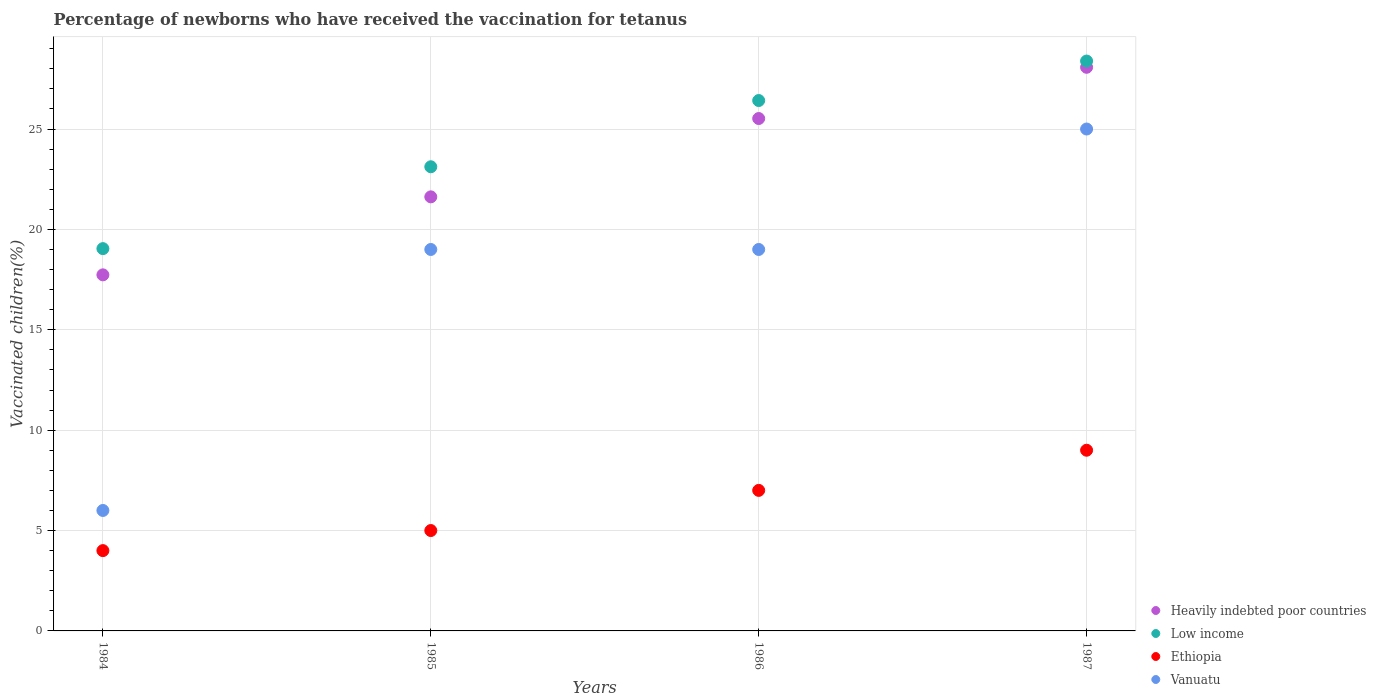How many different coloured dotlines are there?
Your response must be concise. 4. Is the number of dotlines equal to the number of legend labels?
Offer a terse response. Yes. What is the percentage of vaccinated children in Ethiopia in 1987?
Offer a very short reply. 9. Across all years, what is the maximum percentage of vaccinated children in Ethiopia?
Your answer should be very brief. 9. Across all years, what is the minimum percentage of vaccinated children in Low income?
Your answer should be very brief. 19.04. In which year was the percentage of vaccinated children in Heavily indebted poor countries maximum?
Offer a very short reply. 1987. What is the total percentage of vaccinated children in Heavily indebted poor countries in the graph?
Ensure brevity in your answer.  92.95. What is the difference between the percentage of vaccinated children in Low income in 1985 and that in 1986?
Make the answer very short. -3.3. What is the difference between the percentage of vaccinated children in Low income in 1984 and the percentage of vaccinated children in Heavily indebted poor countries in 1986?
Provide a short and direct response. -6.48. What is the average percentage of vaccinated children in Low income per year?
Provide a short and direct response. 24.24. In the year 1985, what is the difference between the percentage of vaccinated children in Ethiopia and percentage of vaccinated children in Heavily indebted poor countries?
Ensure brevity in your answer.  -16.62. In how many years, is the percentage of vaccinated children in Heavily indebted poor countries greater than 13 %?
Provide a succinct answer. 4. What is the ratio of the percentage of vaccinated children in Ethiopia in 1985 to that in 1987?
Keep it short and to the point. 0.56. What is the difference between the highest and the second highest percentage of vaccinated children in Low income?
Make the answer very short. 1.97. What is the difference between the highest and the lowest percentage of vaccinated children in Heavily indebted poor countries?
Give a very brief answer. 10.34. In how many years, is the percentage of vaccinated children in Low income greater than the average percentage of vaccinated children in Low income taken over all years?
Your answer should be very brief. 2. Is the sum of the percentage of vaccinated children in Heavily indebted poor countries in 1986 and 1987 greater than the maximum percentage of vaccinated children in Ethiopia across all years?
Provide a short and direct response. Yes. Is it the case that in every year, the sum of the percentage of vaccinated children in Low income and percentage of vaccinated children in Vanuatu  is greater than the sum of percentage of vaccinated children in Heavily indebted poor countries and percentage of vaccinated children in Ethiopia?
Offer a very short reply. No. Is the percentage of vaccinated children in Vanuatu strictly greater than the percentage of vaccinated children in Ethiopia over the years?
Make the answer very short. Yes. Is the percentage of vaccinated children in Heavily indebted poor countries strictly less than the percentage of vaccinated children in Ethiopia over the years?
Keep it short and to the point. No. How many years are there in the graph?
Your answer should be very brief. 4. What is the difference between two consecutive major ticks on the Y-axis?
Provide a succinct answer. 5. Are the values on the major ticks of Y-axis written in scientific E-notation?
Your answer should be very brief. No. How many legend labels are there?
Offer a terse response. 4. What is the title of the graph?
Ensure brevity in your answer.  Percentage of newborns who have received the vaccination for tetanus. What is the label or title of the Y-axis?
Your answer should be compact. Vaccinated children(%). What is the Vaccinated children(%) of Heavily indebted poor countries in 1984?
Keep it short and to the point. 17.74. What is the Vaccinated children(%) in Low income in 1984?
Ensure brevity in your answer.  19.04. What is the Vaccinated children(%) in Heavily indebted poor countries in 1985?
Ensure brevity in your answer.  21.62. What is the Vaccinated children(%) in Low income in 1985?
Offer a very short reply. 23.12. What is the Vaccinated children(%) of Ethiopia in 1985?
Your response must be concise. 5. What is the Vaccinated children(%) in Vanuatu in 1985?
Ensure brevity in your answer.  19. What is the Vaccinated children(%) of Heavily indebted poor countries in 1986?
Your response must be concise. 25.52. What is the Vaccinated children(%) in Low income in 1986?
Make the answer very short. 26.42. What is the Vaccinated children(%) of Heavily indebted poor countries in 1987?
Give a very brief answer. 28.07. What is the Vaccinated children(%) of Low income in 1987?
Give a very brief answer. 28.39. What is the Vaccinated children(%) in Ethiopia in 1987?
Keep it short and to the point. 9. What is the Vaccinated children(%) of Vanuatu in 1987?
Give a very brief answer. 25. Across all years, what is the maximum Vaccinated children(%) in Heavily indebted poor countries?
Provide a short and direct response. 28.07. Across all years, what is the maximum Vaccinated children(%) in Low income?
Provide a short and direct response. 28.39. Across all years, what is the maximum Vaccinated children(%) of Ethiopia?
Your answer should be very brief. 9. Across all years, what is the minimum Vaccinated children(%) of Heavily indebted poor countries?
Your answer should be very brief. 17.74. Across all years, what is the minimum Vaccinated children(%) in Low income?
Give a very brief answer. 19.04. Across all years, what is the minimum Vaccinated children(%) of Vanuatu?
Offer a terse response. 6. What is the total Vaccinated children(%) in Heavily indebted poor countries in the graph?
Give a very brief answer. 92.95. What is the total Vaccinated children(%) of Low income in the graph?
Offer a very short reply. 96.97. What is the total Vaccinated children(%) in Vanuatu in the graph?
Offer a very short reply. 69. What is the difference between the Vaccinated children(%) in Heavily indebted poor countries in 1984 and that in 1985?
Keep it short and to the point. -3.89. What is the difference between the Vaccinated children(%) in Low income in 1984 and that in 1985?
Provide a succinct answer. -4.08. What is the difference between the Vaccinated children(%) of Ethiopia in 1984 and that in 1985?
Keep it short and to the point. -1. What is the difference between the Vaccinated children(%) in Vanuatu in 1984 and that in 1985?
Offer a terse response. -13. What is the difference between the Vaccinated children(%) of Heavily indebted poor countries in 1984 and that in 1986?
Keep it short and to the point. -7.79. What is the difference between the Vaccinated children(%) of Low income in 1984 and that in 1986?
Make the answer very short. -7.38. What is the difference between the Vaccinated children(%) of Vanuatu in 1984 and that in 1986?
Offer a terse response. -13. What is the difference between the Vaccinated children(%) in Heavily indebted poor countries in 1984 and that in 1987?
Give a very brief answer. -10.34. What is the difference between the Vaccinated children(%) in Low income in 1984 and that in 1987?
Make the answer very short. -9.34. What is the difference between the Vaccinated children(%) in Ethiopia in 1984 and that in 1987?
Ensure brevity in your answer.  -5. What is the difference between the Vaccinated children(%) of Vanuatu in 1984 and that in 1987?
Your answer should be compact. -19. What is the difference between the Vaccinated children(%) in Heavily indebted poor countries in 1985 and that in 1986?
Make the answer very short. -3.9. What is the difference between the Vaccinated children(%) in Low income in 1985 and that in 1986?
Your answer should be very brief. -3.3. What is the difference between the Vaccinated children(%) of Ethiopia in 1985 and that in 1986?
Give a very brief answer. -2. What is the difference between the Vaccinated children(%) in Vanuatu in 1985 and that in 1986?
Your answer should be compact. 0. What is the difference between the Vaccinated children(%) in Heavily indebted poor countries in 1985 and that in 1987?
Your response must be concise. -6.45. What is the difference between the Vaccinated children(%) in Low income in 1985 and that in 1987?
Keep it short and to the point. -5.27. What is the difference between the Vaccinated children(%) of Ethiopia in 1985 and that in 1987?
Your answer should be very brief. -4. What is the difference between the Vaccinated children(%) in Heavily indebted poor countries in 1986 and that in 1987?
Give a very brief answer. -2.55. What is the difference between the Vaccinated children(%) in Low income in 1986 and that in 1987?
Offer a very short reply. -1.97. What is the difference between the Vaccinated children(%) in Heavily indebted poor countries in 1984 and the Vaccinated children(%) in Low income in 1985?
Offer a very short reply. -5.38. What is the difference between the Vaccinated children(%) in Heavily indebted poor countries in 1984 and the Vaccinated children(%) in Ethiopia in 1985?
Your response must be concise. 12.74. What is the difference between the Vaccinated children(%) of Heavily indebted poor countries in 1984 and the Vaccinated children(%) of Vanuatu in 1985?
Give a very brief answer. -1.26. What is the difference between the Vaccinated children(%) of Low income in 1984 and the Vaccinated children(%) of Ethiopia in 1985?
Your answer should be very brief. 14.04. What is the difference between the Vaccinated children(%) of Low income in 1984 and the Vaccinated children(%) of Vanuatu in 1985?
Make the answer very short. 0.04. What is the difference between the Vaccinated children(%) in Ethiopia in 1984 and the Vaccinated children(%) in Vanuatu in 1985?
Provide a short and direct response. -15. What is the difference between the Vaccinated children(%) of Heavily indebted poor countries in 1984 and the Vaccinated children(%) of Low income in 1986?
Provide a succinct answer. -8.68. What is the difference between the Vaccinated children(%) of Heavily indebted poor countries in 1984 and the Vaccinated children(%) of Ethiopia in 1986?
Offer a very short reply. 10.74. What is the difference between the Vaccinated children(%) of Heavily indebted poor countries in 1984 and the Vaccinated children(%) of Vanuatu in 1986?
Your answer should be very brief. -1.26. What is the difference between the Vaccinated children(%) of Low income in 1984 and the Vaccinated children(%) of Ethiopia in 1986?
Your answer should be very brief. 12.04. What is the difference between the Vaccinated children(%) of Low income in 1984 and the Vaccinated children(%) of Vanuatu in 1986?
Offer a terse response. 0.04. What is the difference between the Vaccinated children(%) in Heavily indebted poor countries in 1984 and the Vaccinated children(%) in Low income in 1987?
Keep it short and to the point. -10.65. What is the difference between the Vaccinated children(%) in Heavily indebted poor countries in 1984 and the Vaccinated children(%) in Ethiopia in 1987?
Keep it short and to the point. 8.74. What is the difference between the Vaccinated children(%) in Heavily indebted poor countries in 1984 and the Vaccinated children(%) in Vanuatu in 1987?
Give a very brief answer. -7.26. What is the difference between the Vaccinated children(%) of Low income in 1984 and the Vaccinated children(%) of Ethiopia in 1987?
Your answer should be very brief. 10.04. What is the difference between the Vaccinated children(%) in Low income in 1984 and the Vaccinated children(%) in Vanuatu in 1987?
Ensure brevity in your answer.  -5.96. What is the difference between the Vaccinated children(%) in Ethiopia in 1984 and the Vaccinated children(%) in Vanuatu in 1987?
Keep it short and to the point. -21. What is the difference between the Vaccinated children(%) of Heavily indebted poor countries in 1985 and the Vaccinated children(%) of Low income in 1986?
Make the answer very short. -4.8. What is the difference between the Vaccinated children(%) of Heavily indebted poor countries in 1985 and the Vaccinated children(%) of Ethiopia in 1986?
Give a very brief answer. 14.62. What is the difference between the Vaccinated children(%) in Heavily indebted poor countries in 1985 and the Vaccinated children(%) in Vanuatu in 1986?
Make the answer very short. 2.62. What is the difference between the Vaccinated children(%) in Low income in 1985 and the Vaccinated children(%) in Ethiopia in 1986?
Your response must be concise. 16.12. What is the difference between the Vaccinated children(%) of Low income in 1985 and the Vaccinated children(%) of Vanuatu in 1986?
Provide a short and direct response. 4.12. What is the difference between the Vaccinated children(%) in Ethiopia in 1985 and the Vaccinated children(%) in Vanuatu in 1986?
Your response must be concise. -14. What is the difference between the Vaccinated children(%) of Heavily indebted poor countries in 1985 and the Vaccinated children(%) of Low income in 1987?
Ensure brevity in your answer.  -6.76. What is the difference between the Vaccinated children(%) in Heavily indebted poor countries in 1985 and the Vaccinated children(%) in Ethiopia in 1987?
Offer a terse response. 12.62. What is the difference between the Vaccinated children(%) of Heavily indebted poor countries in 1985 and the Vaccinated children(%) of Vanuatu in 1987?
Provide a succinct answer. -3.38. What is the difference between the Vaccinated children(%) in Low income in 1985 and the Vaccinated children(%) in Ethiopia in 1987?
Provide a succinct answer. 14.12. What is the difference between the Vaccinated children(%) in Low income in 1985 and the Vaccinated children(%) in Vanuatu in 1987?
Ensure brevity in your answer.  -1.88. What is the difference between the Vaccinated children(%) in Ethiopia in 1985 and the Vaccinated children(%) in Vanuatu in 1987?
Offer a very short reply. -20. What is the difference between the Vaccinated children(%) in Heavily indebted poor countries in 1986 and the Vaccinated children(%) in Low income in 1987?
Keep it short and to the point. -2.86. What is the difference between the Vaccinated children(%) of Heavily indebted poor countries in 1986 and the Vaccinated children(%) of Ethiopia in 1987?
Give a very brief answer. 16.52. What is the difference between the Vaccinated children(%) in Heavily indebted poor countries in 1986 and the Vaccinated children(%) in Vanuatu in 1987?
Your answer should be compact. 0.52. What is the difference between the Vaccinated children(%) of Low income in 1986 and the Vaccinated children(%) of Ethiopia in 1987?
Offer a very short reply. 17.42. What is the difference between the Vaccinated children(%) of Low income in 1986 and the Vaccinated children(%) of Vanuatu in 1987?
Keep it short and to the point. 1.42. What is the difference between the Vaccinated children(%) of Ethiopia in 1986 and the Vaccinated children(%) of Vanuatu in 1987?
Provide a short and direct response. -18. What is the average Vaccinated children(%) in Heavily indebted poor countries per year?
Provide a succinct answer. 23.24. What is the average Vaccinated children(%) of Low income per year?
Offer a terse response. 24.24. What is the average Vaccinated children(%) in Ethiopia per year?
Give a very brief answer. 6.25. What is the average Vaccinated children(%) of Vanuatu per year?
Provide a succinct answer. 17.25. In the year 1984, what is the difference between the Vaccinated children(%) of Heavily indebted poor countries and Vaccinated children(%) of Low income?
Your response must be concise. -1.31. In the year 1984, what is the difference between the Vaccinated children(%) in Heavily indebted poor countries and Vaccinated children(%) in Ethiopia?
Provide a succinct answer. 13.74. In the year 1984, what is the difference between the Vaccinated children(%) in Heavily indebted poor countries and Vaccinated children(%) in Vanuatu?
Your answer should be compact. 11.74. In the year 1984, what is the difference between the Vaccinated children(%) of Low income and Vaccinated children(%) of Ethiopia?
Provide a succinct answer. 15.04. In the year 1984, what is the difference between the Vaccinated children(%) of Low income and Vaccinated children(%) of Vanuatu?
Offer a terse response. 13.04. In the year 1984, what is the difference between the Vaccinated children(%) of Ethiopia and Vaccinated children(%) of Vanuatu?
Ensure brevity in your answer.  -2. In the year 1985, what is the difference between the Vaccinated children(%) of Heavily indebted poor countries and Vaccinated children(%) of Low income?
Keep it short and to the point. -1.5. In the year 1985, what is the difference between the Vaccinated children(%) in Heavily indebted poor countries and Vaccinated children(%) in Ethiopia?
Your response must be concise. 16.62. In the year 1985, what is the difference between the Vaccinated children(%) in Heavily indebted poor countries and Vaccinated children(%) in Vanuatu?
Make the answer very short. 2.62. In the year 1985, what is the difference between the Vaccinated children(%) of Low income and Vaccinated children(%) of Ethiopia?
Make the answer very short. 18.12. In the year 1985, what is the difference between the Vaccinated children(%) of Low income and Vaccinated children(%) of Vanuatu?
Ensure brevity in your answer.  4.12. In the year 1985, what is the difference between the Vaccinated children(%) in Ethiopia and Vaccinated children(%) in Vanuatu?
Your response must be concise. -14. In the year 1986, what is the difference between the Vaccinated children(%) in Heavily indebted poor countries and Vaccinated children(%) in Low income?
Give a very brief answer. -0.9. In the year 1986, what is the difference between the Vaccinated children(%) of Heavily indebted poor countries and Vaccinated children(%) of Ethiopia?
Make the answer very short. 18.52. In the year 1986, what is the difference between the Vaccinated children(%) of Heavily indebted poor countries and Vaccinated children(%) of Vanuatu?
Give a very brief answer. 6.52. In the year 1986, what is the difference between the Vaccinated children(%) in Low income and Vaccinated children(%) in Ethiopia?
Provide a short and direct response. 19.42. In the year 1986, what is the difference between the Vaccinated children(%) in Low income and Vaccinated children(%) in Vanuatu?
Your answer should be very brief. 7.42. In the year 1986, what is the difference between the Vaccinated children(%) in Ethiopia and Vaccinated children(%) in Vanuatu?
Provide a short and direct response. -12. In the year 1987, what is the difference between the Vaccinated children(%) of Heavily indebted poor countries and Vaccinated children(%) of Low income?
Your answer should be compact. -0.31. In the year 1987, what is the difference between the Vaccinated children(%) in Heavily indebted poor countries and Vaccinated children(%) in Ethiopia?
Offer a terse response. 19.07. In the year 1987, what is the difference between the Vaccinated children(%) in Heavily indebted poor countries and Vaccinated children(%) in Vanuatu?
Ensure brevity in your answer.  3.07. In the year 1987, what is the difference between the Vaccinated children(%) of Low income and Vaccinated children(%) of Ethiopia?
Your answer should be compact. 19.39. In the year 1987, what is the difference between the Vaccinated children(%) of Low income and Vaccinated children(%) of Vanuatu?
Ensure brevity in your answer.  3.39. In the year 1987, what is the difference between the Vaccinated children(%) in Ethiopia and Vaccinated children(%) in Vanuatu?
Keep it short and to the point. -16. What is the ratio of the Vaccinated children(%) of Heavily indebted poor countries in 1984 to that in 1985?
Give a very brief answer. 0.82. What is the ratio of the Vaccinated children(%) of Low income in 1984 to that in 1985?
Keep it short and to the point. 0.82. What is the ratio of the Vaccinated children(%) in Ethiopia in 1984 to that in 1985?
Give a very brief answer. 0.8. What is the ratio of the Vaccinated children(%) of Vanuatu in 1984 to that in 1985?
Make the answer very short. 0.32. What is the ratio of the Vaccinated children(%) of Heavily indebted poor countries in 1984 to that in 1986?
Keep it short and to the point. 0.69. What is the ratio of the Vaccinated children(%) in Low income in 1984 to that in 1986?
Keep it short and to the point. 0.72. What is the ratio of the Vaccinated children(%) in Ethiopia in 1984 to that in 1986?
Your answer should be compact. 0.57. What is the ratio of the Vaccinated children(%) in Vanuatu in 1984 to that in 1986?
Ensure brevity in your answer.  0.32. What is the ratio of the Vaccinated children(%) in Heavily indebted poor countries in 1984 to that in 1987?
Offer a very short reply. 0.63. What is the ratio of the Vaccinated children(%) in Low income in 1984 to that in 1987?
Keep it short and to the point. 0.67. What is the ratio of the Vaccinated children(%) in Ethiopia in 1984 to that in 1987?
Provide a short and direct response. 0.44. What is the ratio of the Vaccinated children(%) of Vanuatu in 1984 to that in 1987?
Provide a short and direct response. 0.24. What is the ratio of the Vaccinated children(%) of Heavily indebted poor countries in 1985 to that in 1986?
Your answer should be compact. 0.85. What is the ratio of the Vaccinated children(%) in Low income in 1985 to that in 1986?
Offer a terse response. 0.88. What is the ratio of the Vaccinated children(%) in Ethiopia in 1985 to that in 1986?
Ensure brevity in your answer.  0.71. What is the ratio of the Vaccinated children(%) in Vanuatu in 1985 to that in 1986?
Give a very brief answer. 1. What is the ratio of the Vaccinated children(%) of Heavily indebted poor countries in 1985 to that in 1987?
Give a very brief answer. 0.77. What is the ratio of the Vaccinated children(%) in Low income in 1985 to that in 1987?
Make the answer very short. 0.81. What is the ratio of the Vaccinated children(%) in Ethiopia in 1985 to that in 1987?
Your answer should be compact. 0.56. What is the ratio of the Vaccinated children(%) of Vanuatu in 1985 to that in 1987?
Your response must be concise. 0.76. What is the ratio of the Vaccinated children(%) of Heavily indebted poor countries in 1986 to that in 1987?
Offer a very short reply. 0.91. What is the ratio of the Vaccinated children(%) of Low income in 1986 to that in 1987?
Your response must be concise. 0.93. What is the ratio of the Vaccinated children(%) in Vanuatu in 1986 to that in 1987?
Give a very brief answer. 0.76. What is the difference between the highest and the second highest Vaccinated children(%) in Heavily indebted poor countries?
Provide a short and direct response. 2.55. What is the difference between the highest and the second highest Vaccinated children(%) in Low income?
Provide a short and direct response. 1.97. What is the difference between the highest and the second highest Vaccinated children(%) in Vanuatu?
Keep it short and to the point. 6. What is the difference between the highest and the lowest Vaccinated children(%) of Heavily indebted poor countries?
Your response must be concise. 10.34. What is the difference between the highest and the lowest Vaccinated children(%) of Low income?
Provide a succinct answer. 9.34. 